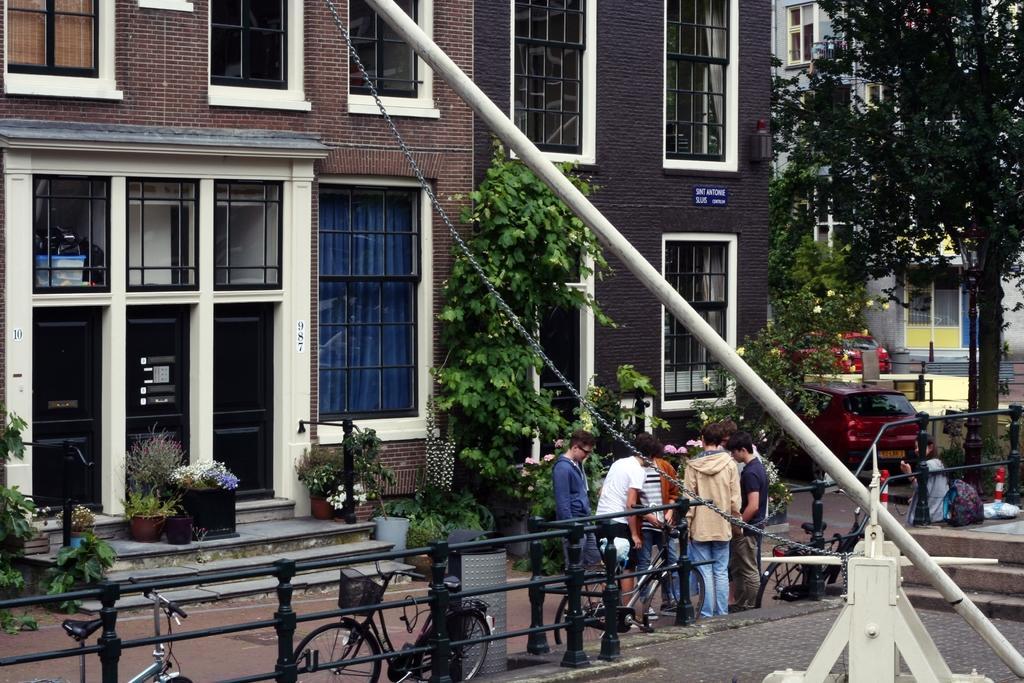How would you summarize this image in a sentence or two? In this image we can see building with glass windows. In front of the building stairs, pots, trees, cars, road, bicycles, boys and black color fencing are there. Right bottom of the image white color metal thing with pole is there. 